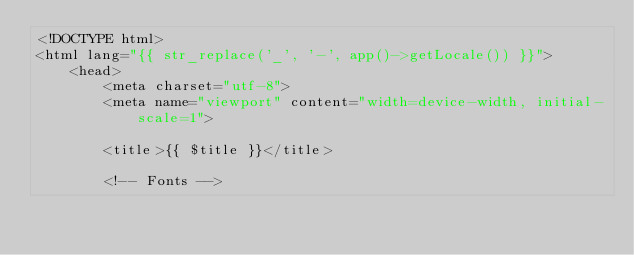<code> <loc_0><loc_0><loc_500><loc_500><_PHP_><!DOCTYPE html>
<html lang="{{ str_replace('_', '-', app()->getLocale()) }}">
    <head>
        <meta charset="utf-8">
        <meta name="viewport" content="width=device-width, initial-scale=1">

        <title>{{ $title }}</title>

        <!-- Fonts --></code> 